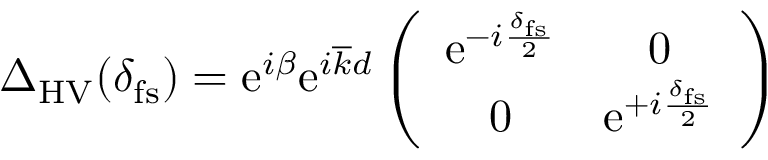<formula> <loc_0><loc_0><loc_500><loc_500>\begin{array} { r } { \Delta _ { H V } ( \delta _ { f s } ) = e ^ { i \beta } e ^ { i \overline { k } d } \left ( \begin{array} { c c } { e ^ { - i \frac { \delta _ { f s } } { 2 } } } & { 0 } \\ { 0 } & { e ^ { + i \frac { \delta _ { f s } } { 2 } } } \end{array} \right ) } \end{array}</formula> 